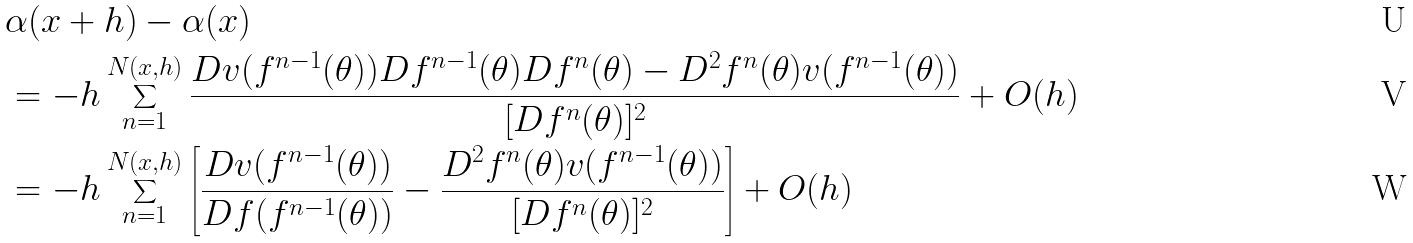Convert formula to latex. <formula><loc_0><loc_0><loc_500><loc_500>& \alpha ( x + h ) - \alpha ( x ) \\ & = - h \sum _ { n = 1 } ^ { N ( x , h ) } \frac { D v ( f ^ { n - 1 } ( \theta ) ) D f ^ { n - 1 } ( \theta ) D f ^ { n } ( \theta ) - D ^ { 2 } f ^ { n } ( \theta ) v ( f ^ { n - 1 } ( \theta ) ) } { [ D f ^ { n } ( \theta ) ] ^ { 2 } } + O ( h ) \\ & = - h \sum _ { n = 1 } ^ { N ( x , h ) } \left [ \frac { D v ( f ^ { n - 1 } ( \theta ) ) } { D f ( f ^ { n - 1 } ( \theta ) ) } - \frac { D ^ { 2 } f ^ { n } ( \theta ) v ( f ^ { n - 1 } ( \theta ) ) } { [ D f ^ { n } ( \theta ) ] ^ { 2 } } \right ] + O ( h )</formula> 